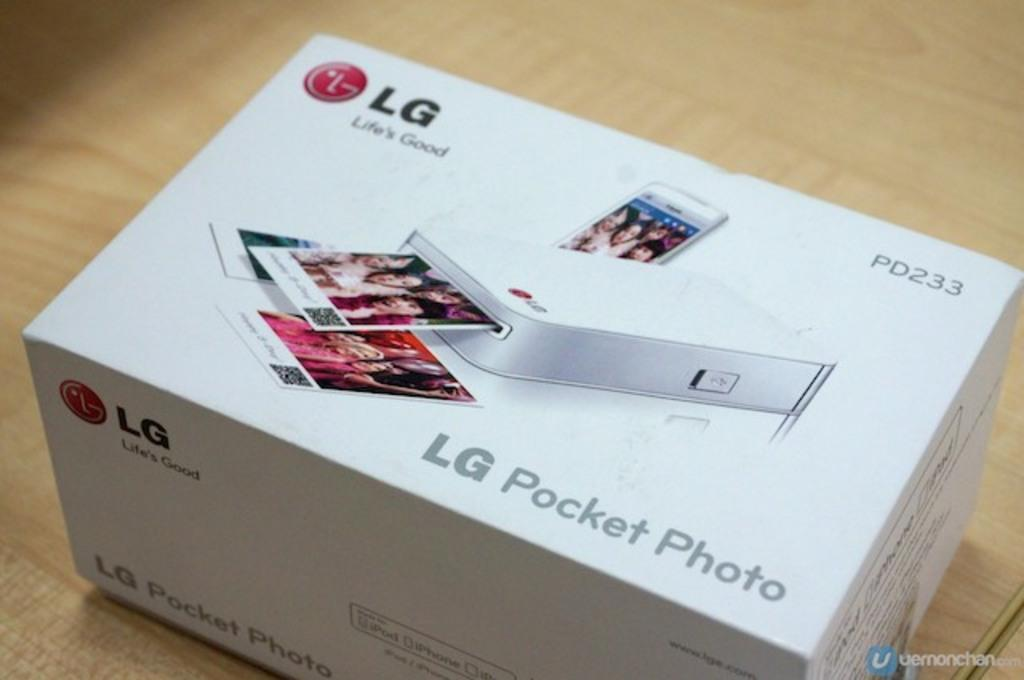<image>
Relay a brief, clear account of the picture shown. an LG pocket photo dispenser PD233 in a new box 